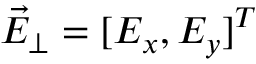Convert formula to latex. <formula><loc_0><loc_0><loc_500><loc_500>\vec { E } _ { \perp } = [ E _ { x } , E _ { y } ] ^ { T }</formula> 